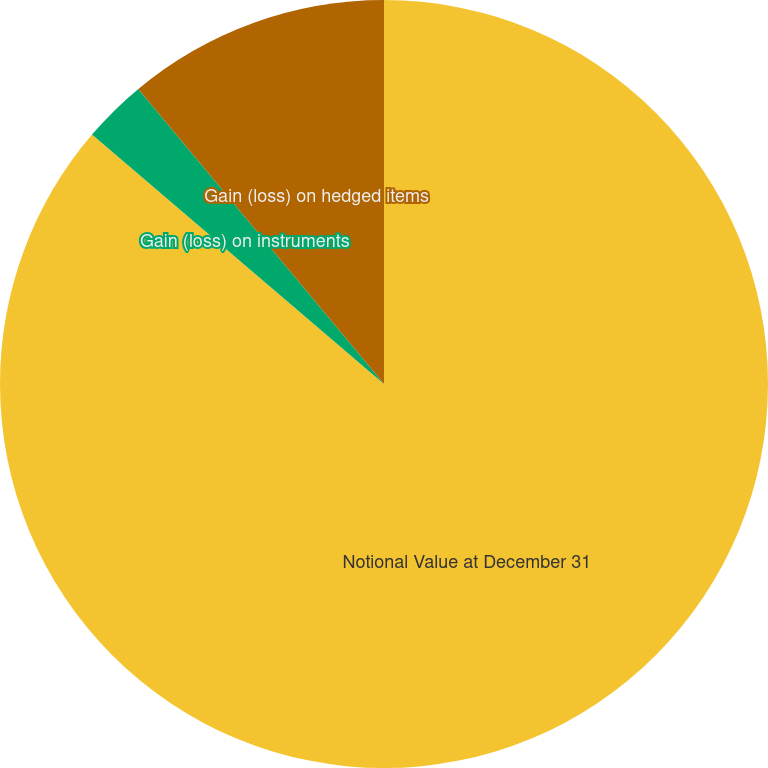Convert chart. <chart><loc_0><loc_0><loc_500><loc_500><pie_chart><fcel>Notional Value at December 31<fcel>Gain (loss) on instruments<fcel>Gain (loss) on hedged items<nl><fcel>86.25%<fcel>2.7%<fcel>11.05%<nl></chart> 